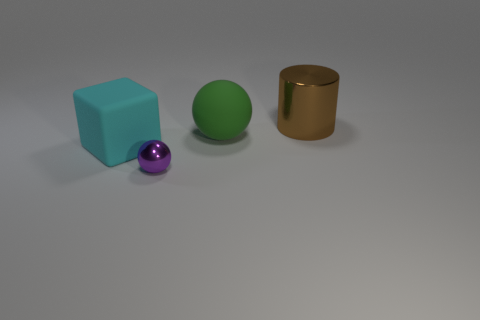How many rubber objects are tiny purple balls or small yellow things?
Ensure brevity in your answer.  0. There is a metal object that is in front of the brown thing; what is its size?
Your answer should be compact. Small. Does the small object have the same shape as the green matte thing?
Offer a very short reply. Yes. How many large objects are either cyan rubber cubes or brown metal cylinders?
Offer a terse response. 2. There is a small purple shiny sphere; are there any large brown cylinders behind it?
Ensure brevity in your answer.  Yes. Is the number of brown metal things that are in front of the big matte cube the same as the number of large metal cylinders?
Make the answer very short. No. There is a purple thing that is the same shape as the big green rubber thing; what is its size?
Make the answer very short. Small. Do the tiny metal thing and the rubber object on the right side of the small purple shiny thing have the same shape?
Provide a succinct answer. Yes. There is a metallic thing in front of the rubber object that is to the right of the tiny thing; how big is it?
Ensure brevity in your answer.  Small. Are there the same number of small purple objects that are on the right side of the big ball and tiny objects that are in front of the tiny purple object?
Offer a terse response. Yes. 